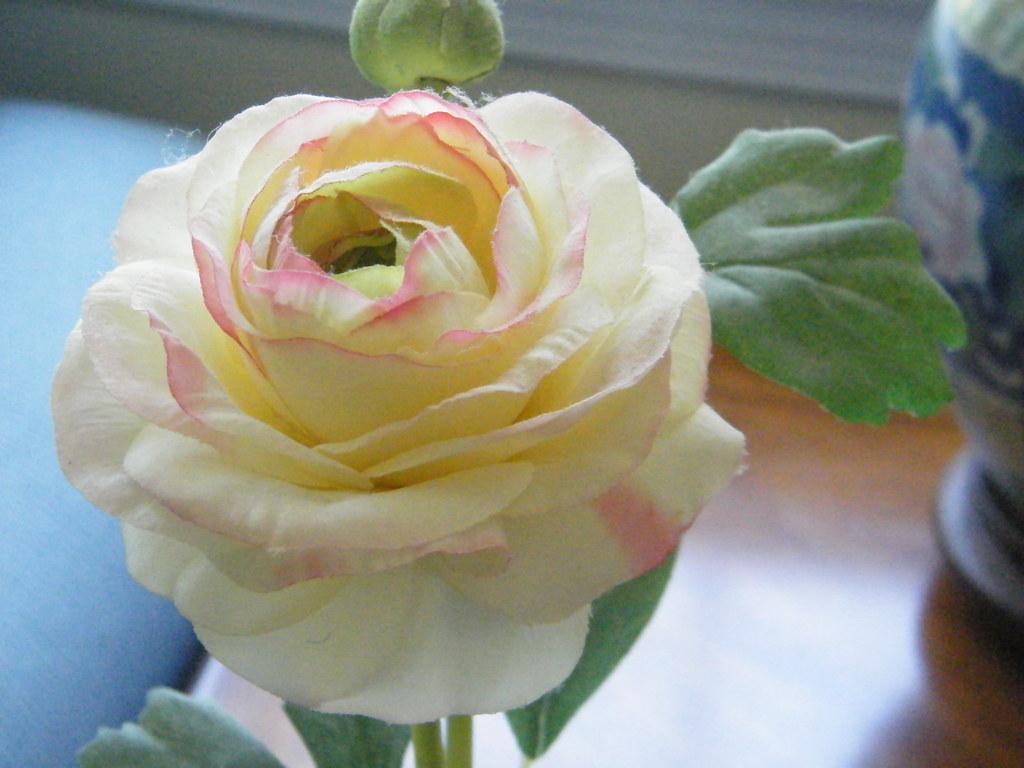Describe this image in one or two sentences. In this image we can see a flower and bud of the plant. In the background, we can see a vase placed on the wooden table. 